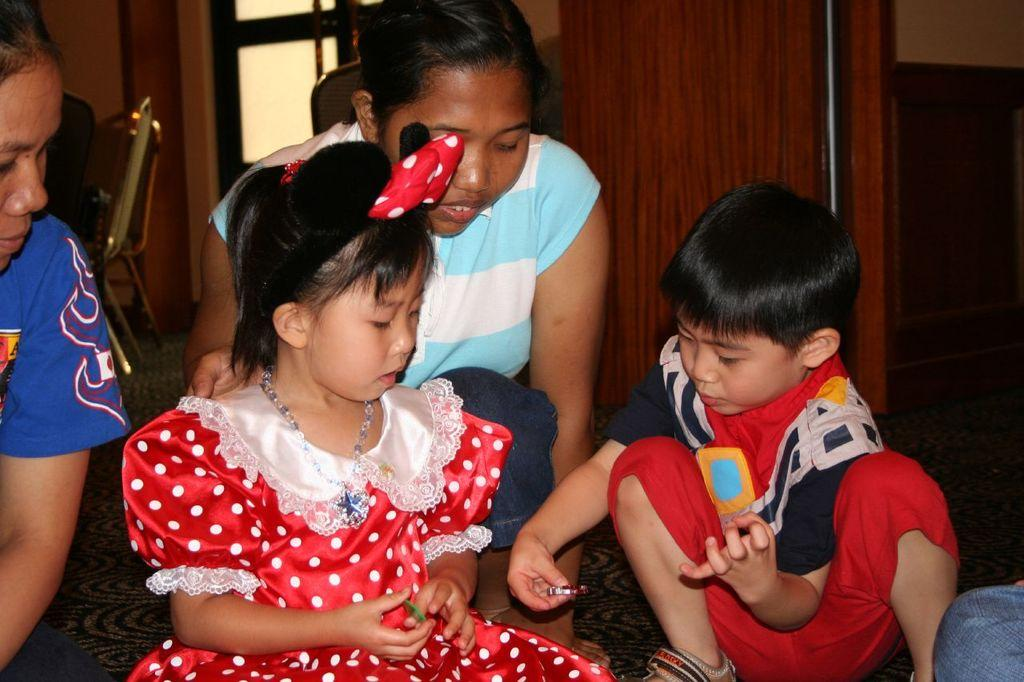Who is present in the image? There is a woman and a girl in the image. What are the woman and the girl wearing? Both the woman and the girl are wearing dresses. Where are the woman and the girl sitting? They are sitting on a couch. What are the other two kids doing in the image? They are in the squat position. What can be seen in the background of the image? There are chairs, a wall, and windows visible in the background. What type of chain is being used for teaching in the image? There is no chain or teaching activity present in the image. 